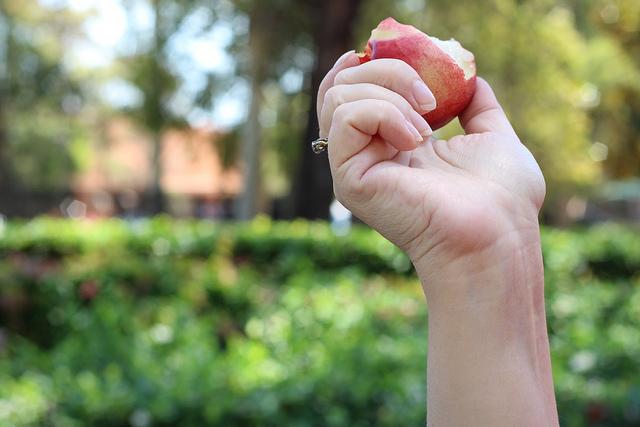Which finger has a ring on it?
Give a very brief answer. Ring finger. Is this a man's hand or a woman's hand?
Keep it brief. Woman's. What fruit is this?
Write a very short answer. Apple. Which hand is holding the apple?
Give a very brief answer. Right. Is this a baby's hand?
Answer briefly. No. Has this person almost finished the apple?
Answer briefly. Yes. 